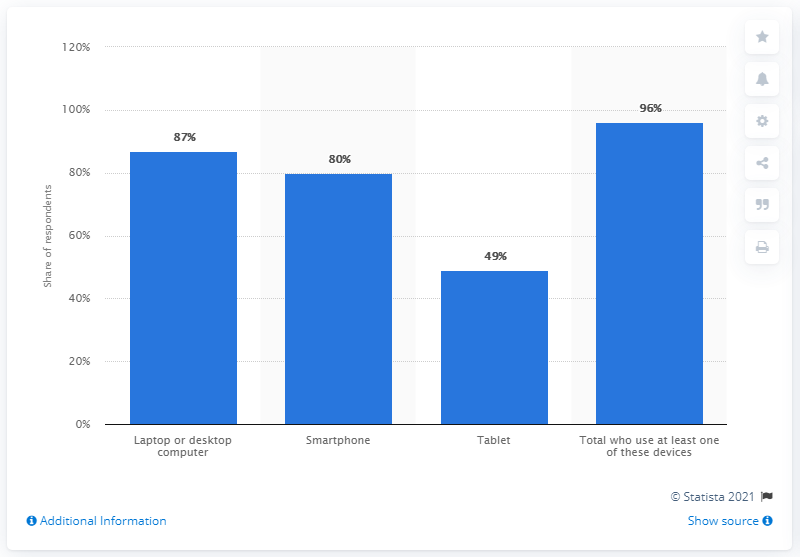Outline some significant characteristics in this image. According to a recent survey, 96% of full-time U.S. employees use at least one of these devices. In the United States, approximately 80% of full-time workers have a smartphone. 